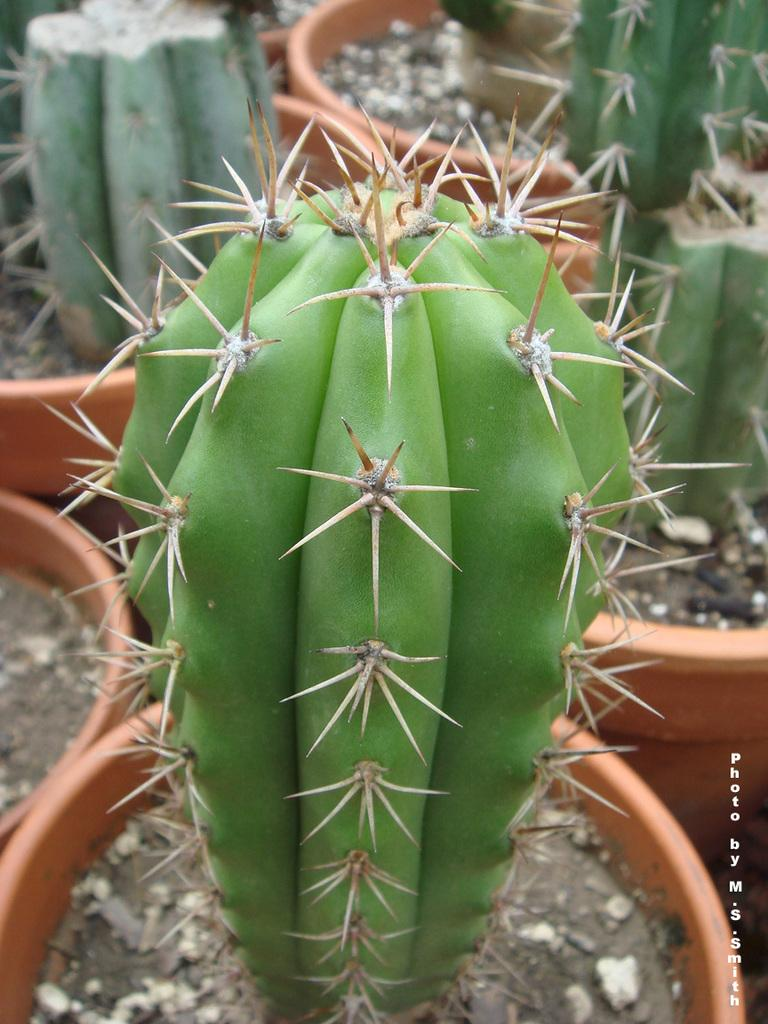What type of plant can be seen in the image? There is a cactus plant in the image. What other types of plants are present in the image? There are flower plants in the image. How much beef is being served at the property in the image? There is no property or beef present in the image; it only features a cactus plant and flower plants. 